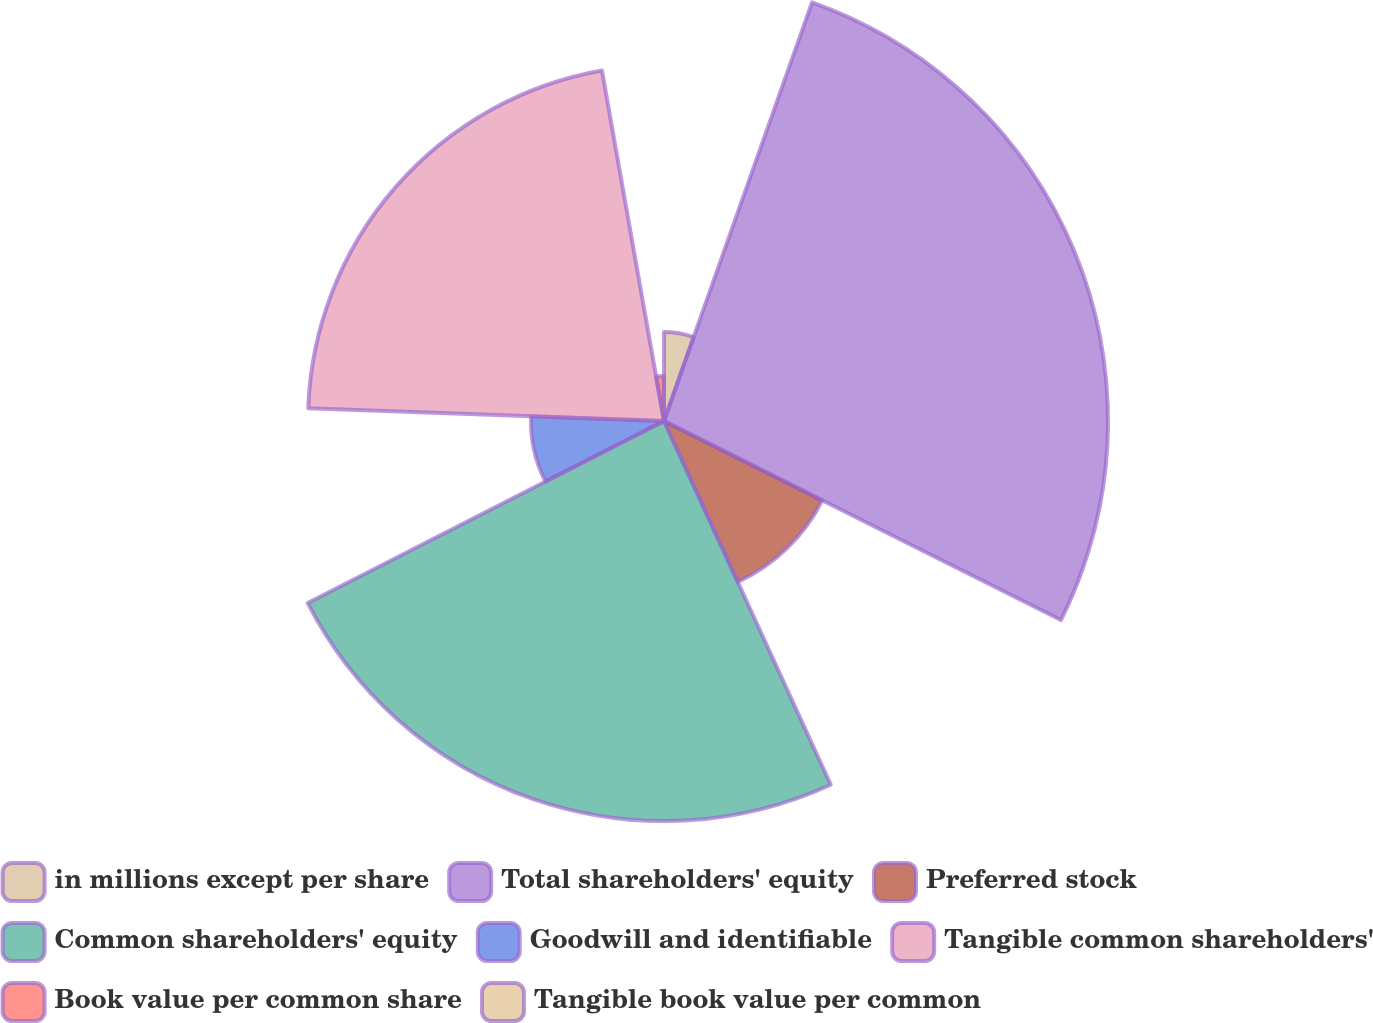<chart> <loc_0><loc_0><loc_500><loc_500><pie_chart><fcel>in millions except per share<fcel>Total shareholders' equity<fcel>Preferred stock<fcel>Common shareholders' equity<fcel>Goodwill and identifiable<fcel>Tangible common shareholders'<fcel>Book value per common share<fcel>Tangible book value per common<nl><fcel>5.41%<fcel>26.99%<fcel>10.76%<fcel>24.32%<fcel>8.09%<fcel>21.64%<fcel>2.73%<fcel>0.06%<nl></chart> 